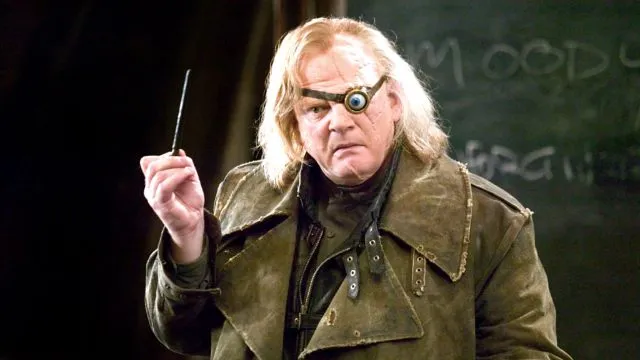Can you describe the significance of the character's costume and props? Certainly. The character's dark green coat and rough texture suggest a battle-worn individual, likely experienced in magical conflicts. The prosthetic eye not only adds a unique visual element but also hints at his depth of experience and perhaps past battles. The wand is a crucial prop, indicating his abilities in cast spells, central to his identity as a wizard. 